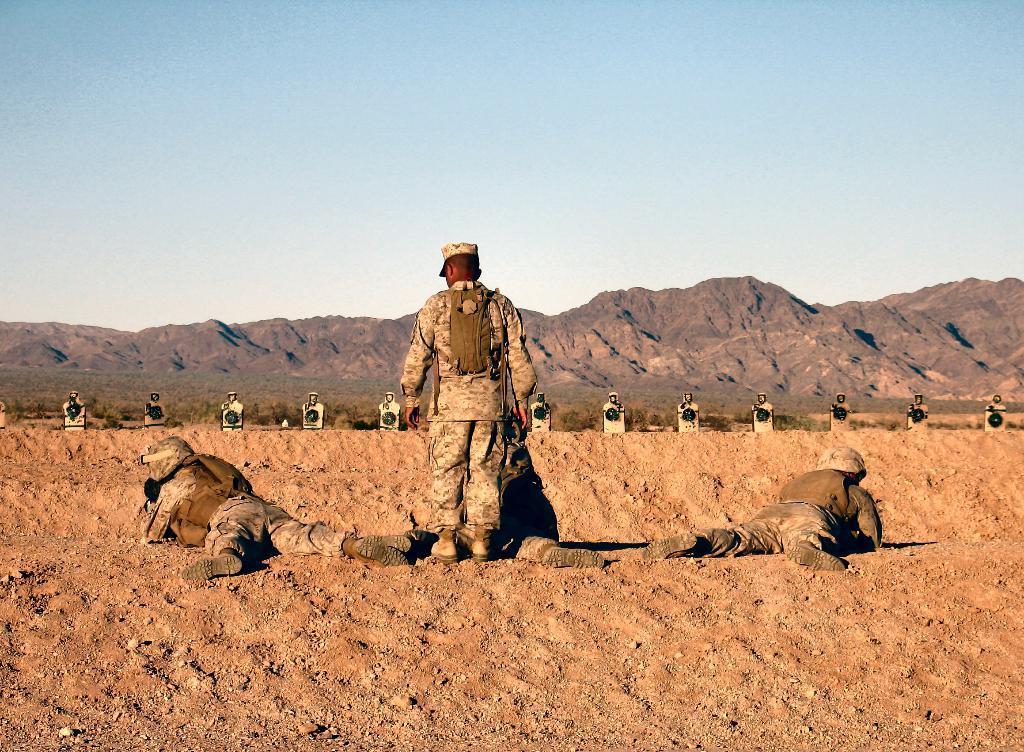In one or two sentences, can you explain what this image depicts? There are two persons lying on the ground and in between them there is a man standing and carrying a bag and some other items on his shoulders. In the background there are some objects,mountains,grass and sky. 